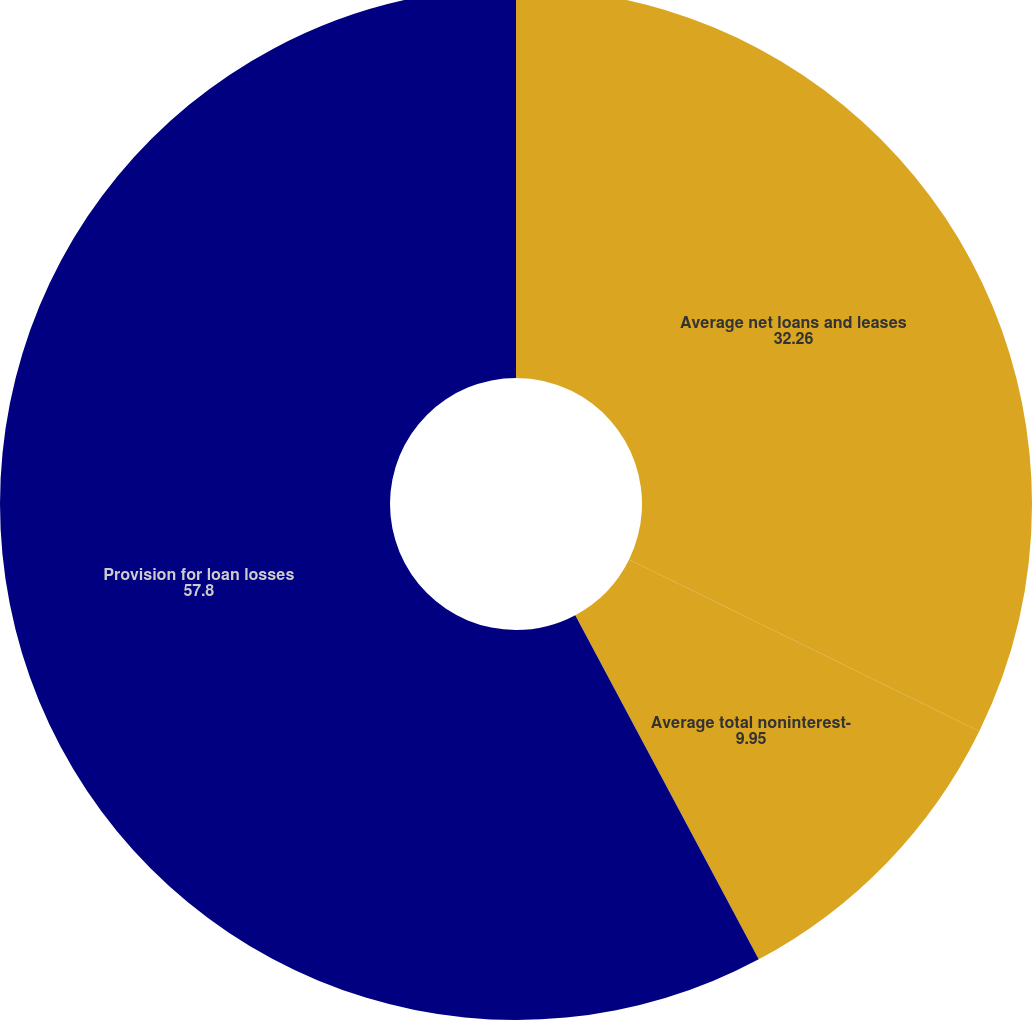Convert chart. <chart><loc_0><loc_0><loc_500><loc_500><pie_chart><fcel>Average net loans and leases<fcel>Average total noninterest-<fcel>Provision for loan losses<nl><fcel>32.26%<fcel>9.95%<fcel>57.8%<nl></chart> 